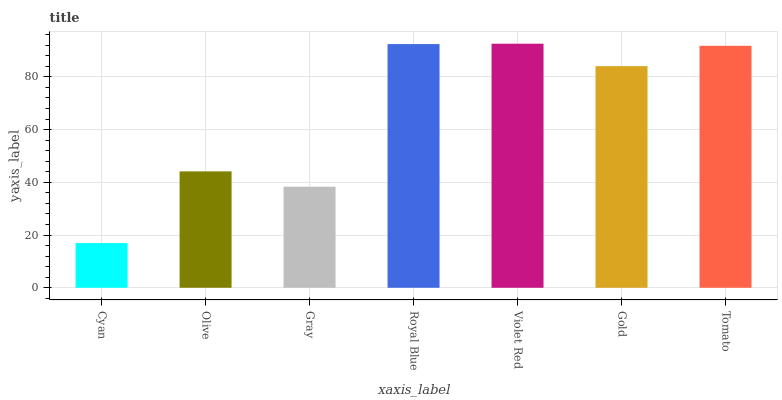Is Cyan the minimum?
Answer yes or no. Yes. Is Violet Red the maximum?
Answer yes or no. Yes. Is Olive the minimum?
Answer yes or no. No. Is Olive the maximum?
Answer yes or no. No. Is Olive greater than Cyan?
Answer yes or no. Yes. Is Cyan less than Olive?
Answer yes or no. Yes. Is Cyan greater than Olive?
Answer yes or no. No. Is Olive less than Cyan?
Answer yes or no. No. Is Gold the high median?
Answer yes or no. Yes. Is Gold the low median?
Answer yes or no. Yes. Is Olive the high median?
Answer yes or no. No. Is Violet Red the low median?
Answer yes or no. No. 